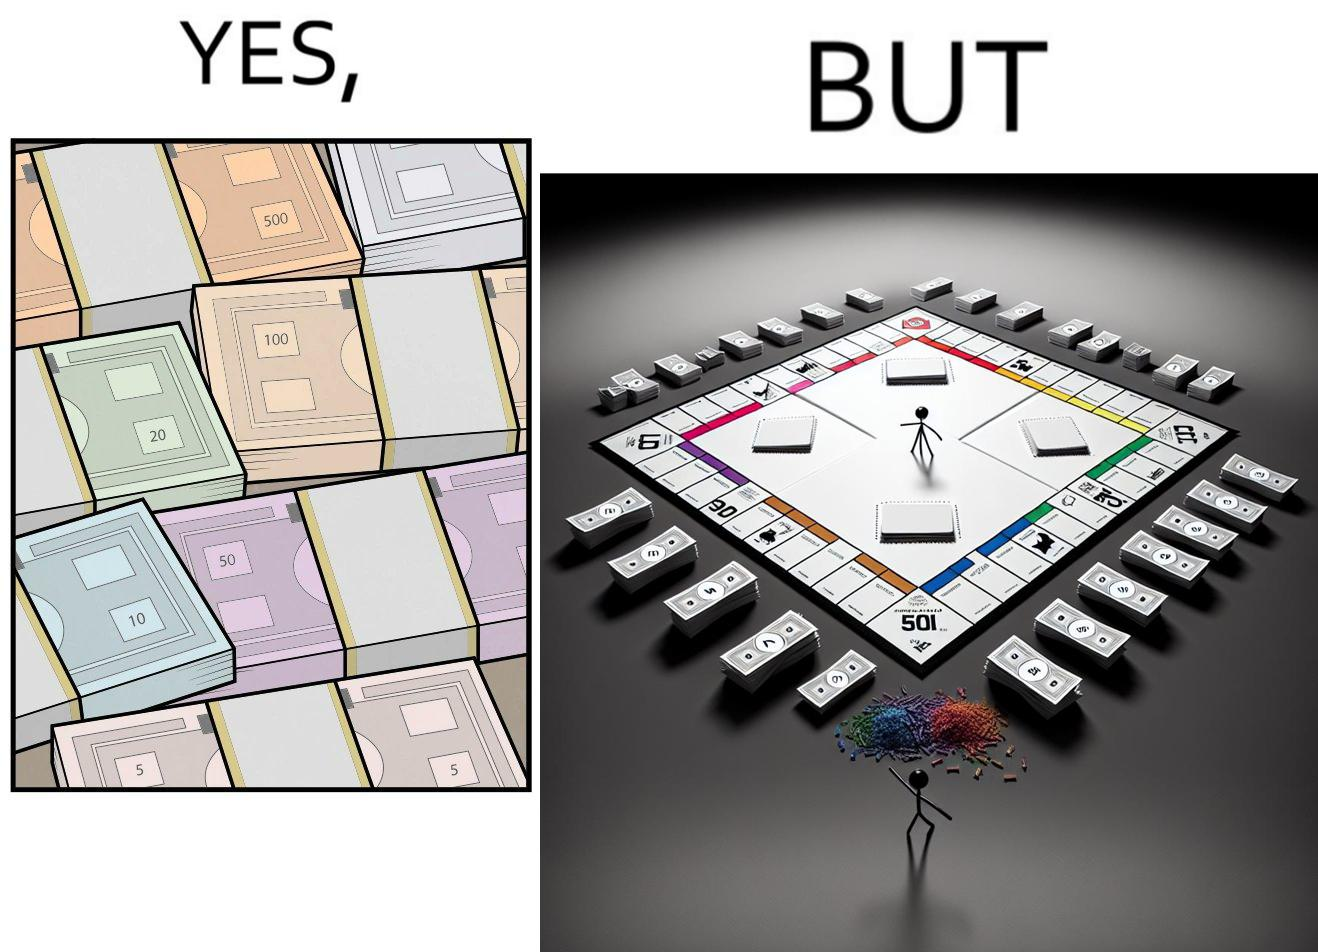What is the satirical meaning behind this image? The image is ironic, because there are many different color currency notes' bundles but they are just as a currency in the game of monopoly and they have no real value 